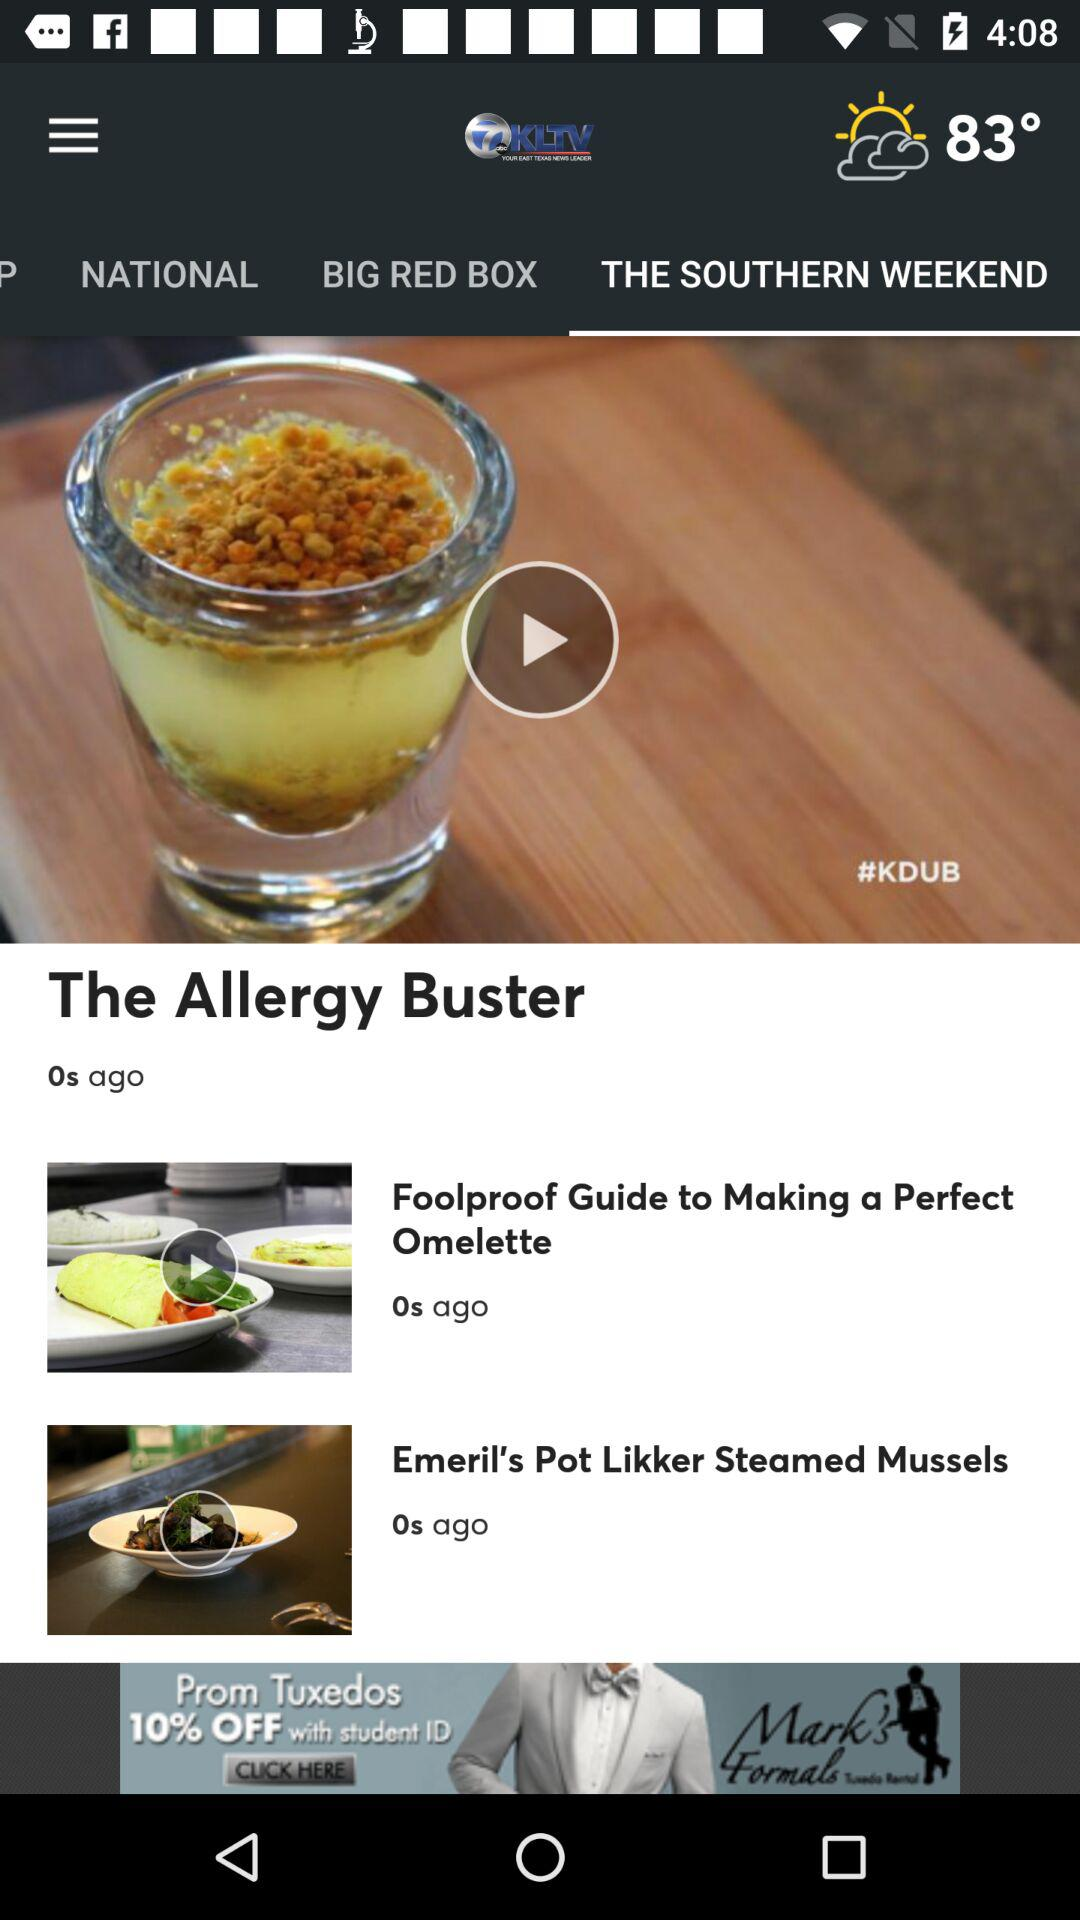What is the temperature? The temperature is 83°. 